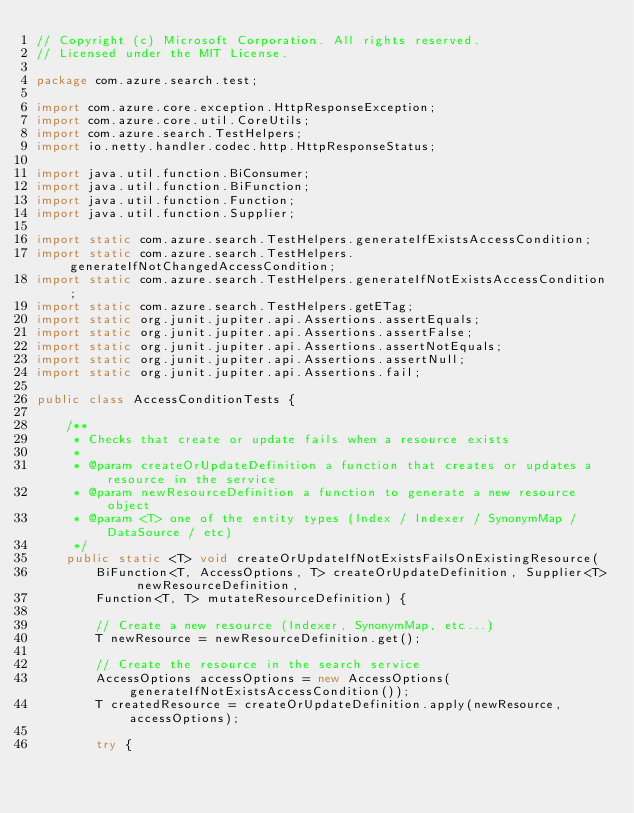<code> <loc_0><loc_0><loc_500><loc_500><_Java_>// Copyright (c) Microsoft Corporation. All rights reserved.
// Licensed under the MIT License.

package com.azure.search.test;

import com.azure.core.exception.HttpResponseException;
import com.azure.core.util.CoreUtils;
import com.azure.search.TestHelpers;
import io.netty.handler.codec.http.HttpResponseStatus;

import java.util.function.BiConsumer;
import java.util.function.BiFunction;
import java.util.function.Function;
import java.util.function.Supplier;

import static com.azure.search.TestHelpers.generateIfExistsAccessCondition;
import static com.azure.search.TestHelpers.generateIfNotChangedAccessCondition;
import static com.azure.search.TestHelpers.generateIfNotExistsAccessCondition;
import static com.azure.search.TestHelpers.getETag;
import static org.junit.jupiter.api.Assertions.assertEquals;
import static org.junit.jupiter.api.Assertions.assertFalse;
import static org.junit.jupiter.api.Assertions.assertNotEquals;
import static org.junit.jupiter.api.Assertions.assertNull;
import static org.junit.jupiter.api.Assertions.fail;

public class AccessConditionTests {

    /**
     * Checks that create or update fails when a resource exists
     *
     * @param createOrUpdateDefinition a function that creates or updates a resource in the service
     * @param newResourceDefinition a function to generate a new resource object
     * @param <T> one of the entity types (Index / Indexer / SynonymMap / DataSource / etc)
     */
    public static <T> void createOrUpdateIfNotExistsFailsOnExistingResource(
        BiFunction<T, AccessOptions, T> createOrUpdateDefinition, Supplier<T> newResourceDefinition,
        Function<T, T> mutateResourceDefinition) {

        // Create a new resource (Indexer, SynonymMap, etc...)
        T newResource = newResourceDefinition.get();

        // Create the resource in the search service
        AccessOptions accessOptions = new AccessOptions(generateIfNotExistsAccessCondition());
        T createdResource = createOrUpdateDefinition.apply(newResource, accessOptions);

        try {</code> 